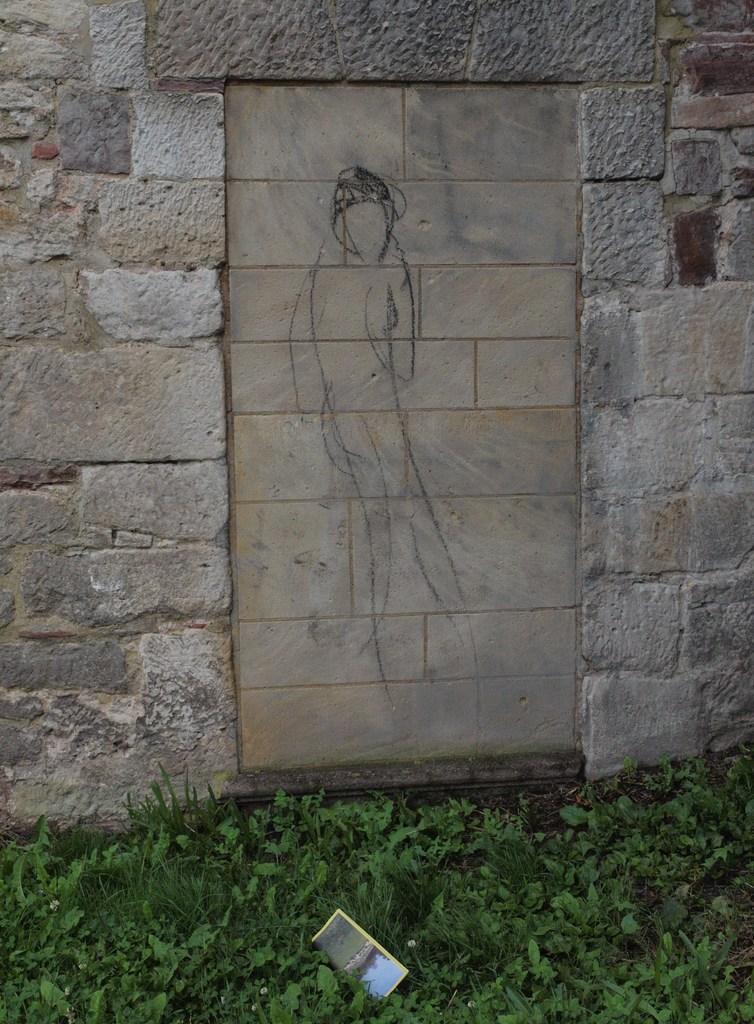Describe this image in one or two sentences. In this image we can see a wall built with stones and some drawing on it. On the bottom of the image we can see a paper on the ground. We can also see some plants and grass. 